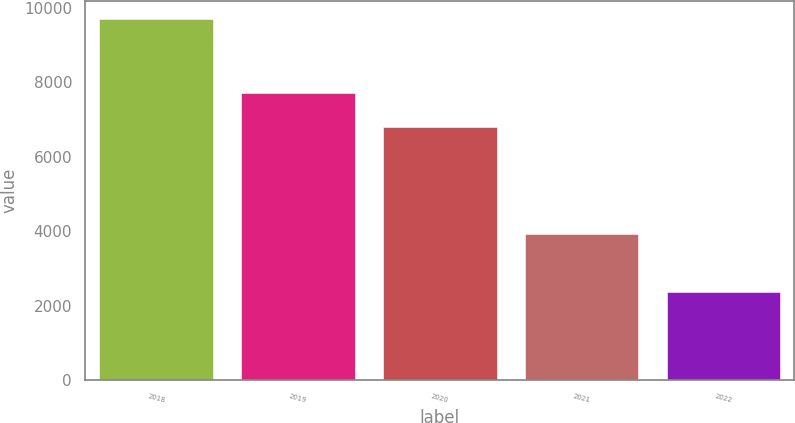Convert chart. <chart><loc_0><loc_0><loc_500><loc_500><bar_chart><fcel>2018<fcel>2019<fcel>2020<fcel>2021<fcel>2022<nl><fcel>9700<fcel>7716<fcel>6783<fcel>3927<fcel>2365<nl></chart> 